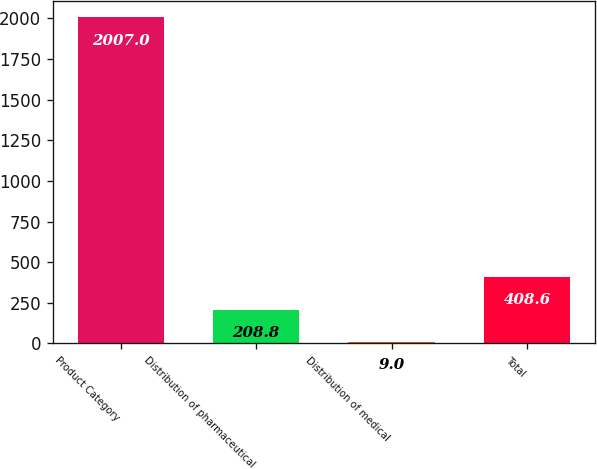<chart> <loc_0><loc_0><loc_500><loc_500><bar_chart><fcel>Product Category<fcel>Distribution of pharmaceutical<fcel>Distribution of medical<fcel>Total<nl><fcel>2007<fcel>208.8<fcel>9<fcel>408.6<nl></chart> 